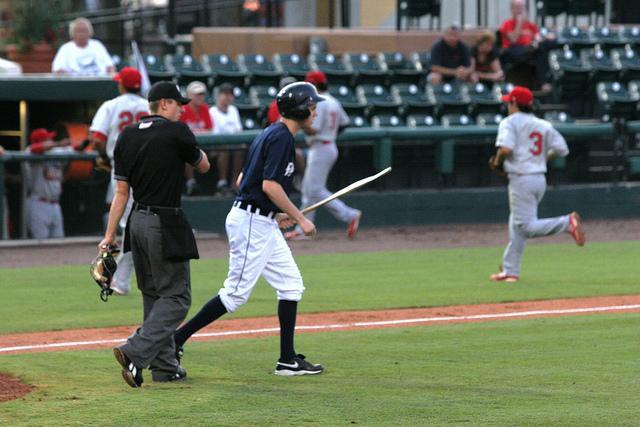What is the pitcher about to do with the bat?
Give a very brief answer. Drop it. What sport is this?
Keep it brief. Baseball. What two colors do most of the fans have on?
Write a very short answer. Red and black. What number Jersey is the player furthest to the right wearing?
Write a very short answer. 3. 